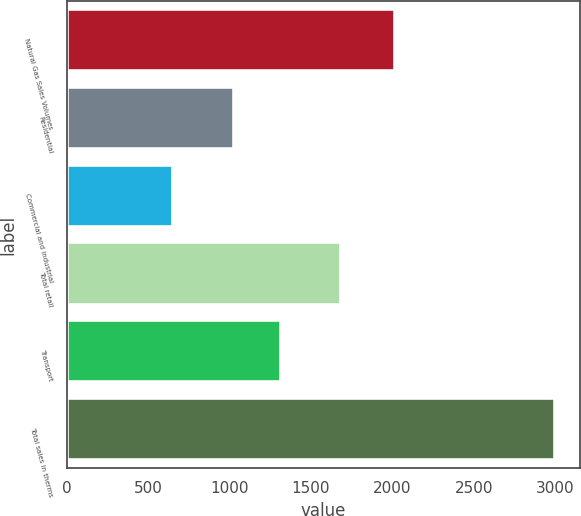Convert chart. <chart><loc_0><loc_0><loc_500><loc_500><bar_chart><fcel>Natural Gas Sales Volumes<fcel>Residential<fcel>Commercial and industrial<fcel>Total retail<fcel>Transport<fcel>Total sales in therms<nl><fcel>2017<fcel>1028.3<fcel>654.7<fcel>1683<fcel>1316.4<fcel>2999.4<nl></chart> 